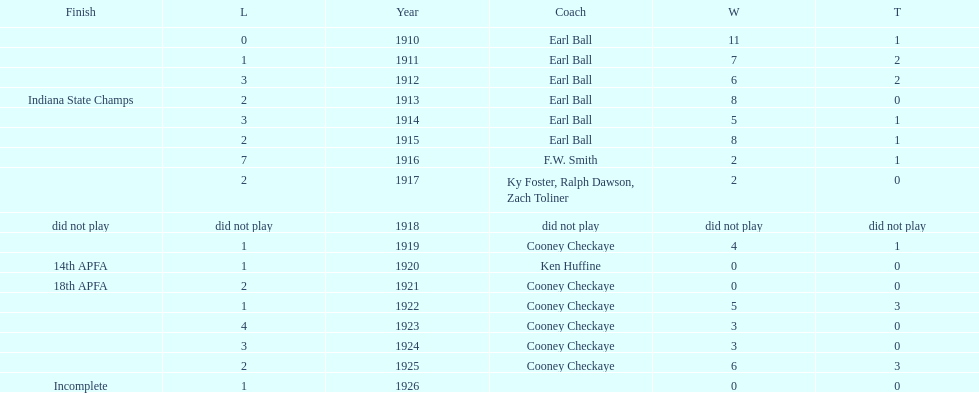In what year did the muncie flyers have an undefeated record? 1910. 